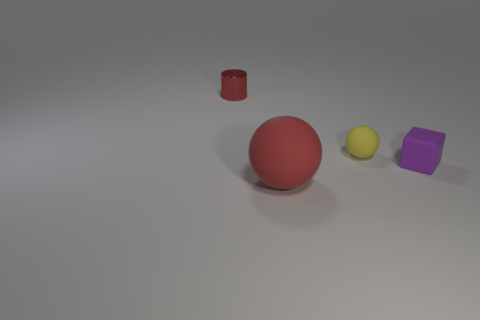Add 2 yellow matte spheres. How many yellow matte spheres exist? 3 Add 1 tiny cyan cylinders. How many objects exist? 5 Subtract all red balls. How many balls are left? 1 Subtract 0 red blocks. How many objects are left? 4 Subtract 1 blocks. How many blocks are left? 0 Subtract all brown blocks. Subtract all blue cylinders. How many blocks are left? 1 Subtract all blue balls. How many green cylinders are left? 0 Subtract all tiny purple cylinders. Subtract all small red objects. How many objects are left? 3 Add 4 small yellow rubber objects. How many small yellow rubber objects are left? 5 